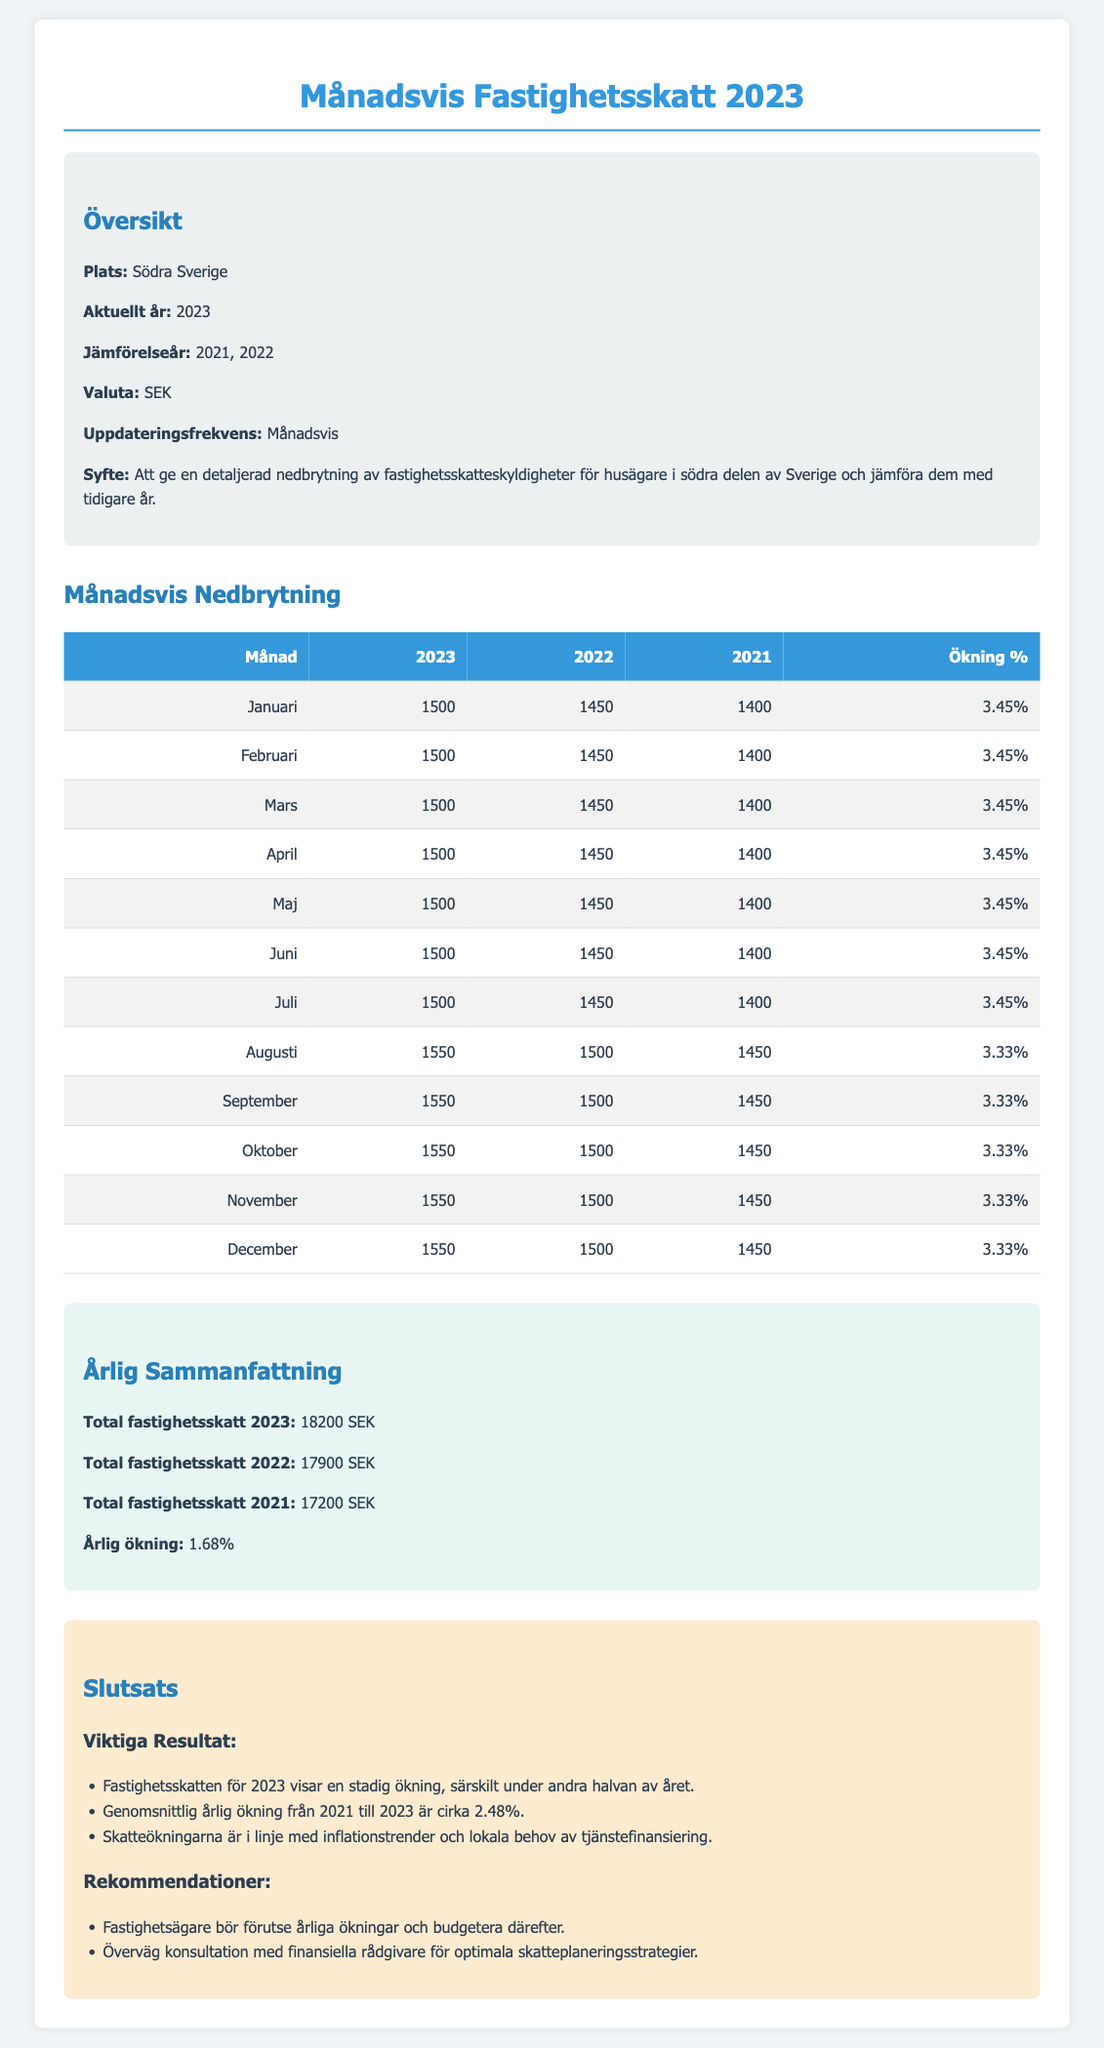what is the total property tax for 2023? The total property tax for 2023 is explicitly mentioned in the document.
Answer: 18200 SEK what was the total property tax for 2022? The total property tax for 2022 is provided in the summary section of the document.
Answer: 17900 SEK how much did the property tax increase from 2021 to 2023? The annual increase from 2021 to 2023 can be derived from the total taxes of both years.
Answer: 1.68% what is the increase percentage for each month in 2023? Each month's increase percentage is listed next to the respective months in the table.
Answer: 3.45% (for January to July), 3.33% (for August to December) how many months are in the overview? The overview includes the months for the entire year specified in the document, totaling to twelve months.
Answer: 12 what was the property tax amount for August in 2021? The property tax amount for August in 2021 is stated in the monthly breakdown table.
Answer: 1450 which month had the highest property tax in 2023? The month with the highest property tax in 2023 can be determined from the monthly breakdown.
Answer: December what is the currency used in the report? The document explicitly states the currency used for the property tax values.
Answer: SEK what is the purpose of the report? The report outlines its purpose clearly in the overview section.
Answer: Att ge en detaljerad nedbrytning av fastighetsskatteskyldigheter 